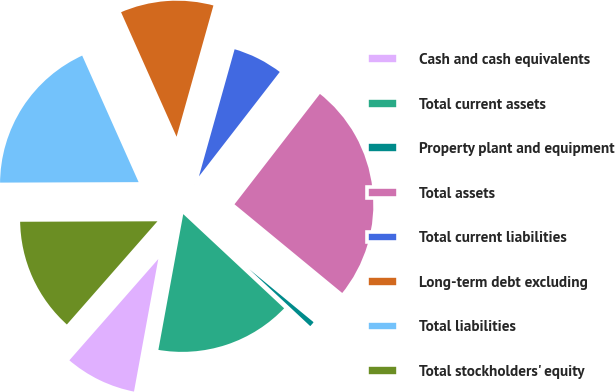Convert chart. <chart><loc_0><loc_0><loc_500><loc_500><pie_chart><fcel>Cash and cash equivalents<fcel>Total current assets<fcel>Property plant and equipment<fcel>Total assets<fcel>Total current liabilities<fcel>Long-term debt excluding<fcel>Total liabilities<fcel>Total stockholders' equity<nl><fcel>8.58%<fcel>15.93%<fcel>0.99%<fcel>25.48%<fcel>6.13%<fcel>11.03%<fcel>18.38%<fcel>13.48%<nl></chart> 